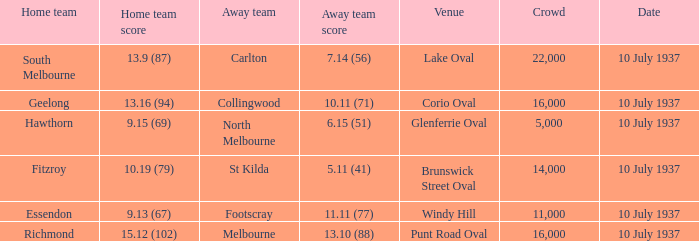What was the Venue of the North Melbourne Away Team? Glenferrie Oval. 